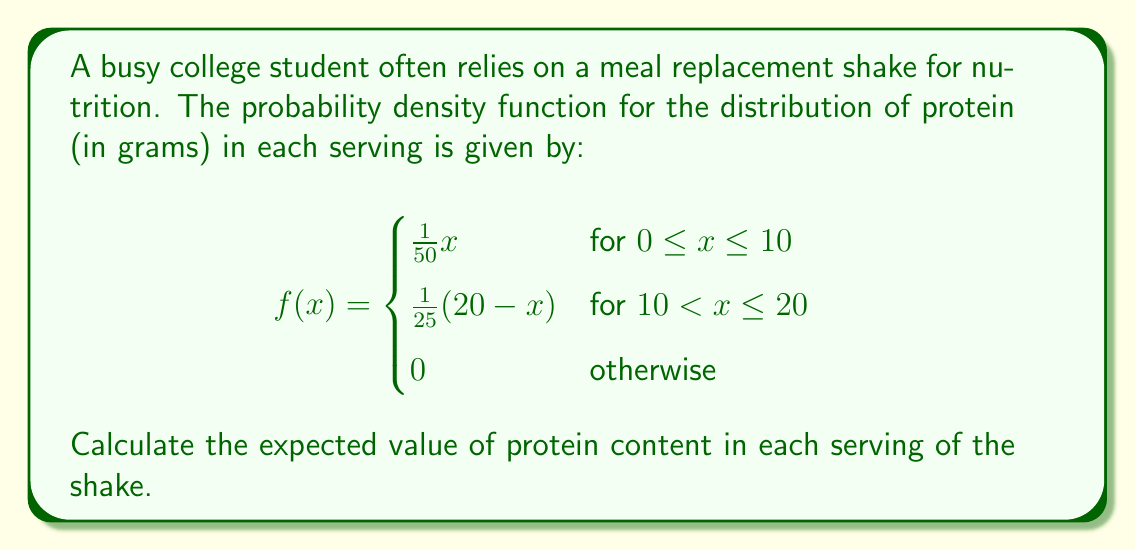Show me your answer to this math problem. To find the expected value of the protein content, we need to calculate:

$$E[X] = \int_{-\infty}^{\infty} xf(x)dx$$

Given the piecewise function, we'll split this into two integrals:

$$E[X] = \int_{0}^{10} x \cdot \frac{1}{50}x dx + \int_{10}^{20} x \cdot \frac{1}{25}(20-x) dx$$

Let's solve each integral separately:

1. For the first integral (0 to 10):
   $$\int_{0}^{10} \frac{1}{50}x^2 dx = \frac{1}{50} \cdot \frac{x^3}{3} \bigg|_{0}^{10} = \frac{1000}{150} = \frac{20}{3}$$

2. For the second integral (10 to 20):
   $$\int_{10}^{20} \frac{1}{25}(20x-x^2) dx = \frac{1}{25} \cdot (10x^2 - \frac{x^3}{3}) \bigg|_{10}^{20}$$
   $$= \frac{1}{25} \cdot [(4000 - \frac{8000}{3}) - (1000 - \frac{1000}{3})]$$
   $$= \frac{1}{25} \cdot (4000 - \frac{8000}{3} - 1000 + \frac{1000}{3})$$
   $$= \frac{1}{25} \cdot (3000 - \frac{7000}{3}) = \frac{2000}{75} = \frac{80}{3}$$

Now, we sum the results:

$$E[X] = \frac{20}{3} + \frac{80}{3} = \frac{100}{3} = 33.33$$

Therefore, the expected value of protein content in each serving is approximately 33.33 grams.
Answer: $\frac{100}{3}$ grams or approximately 33.33 grams 